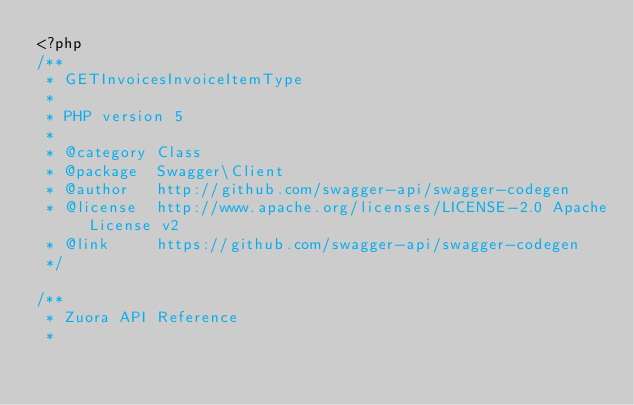Convert code to text. <code><loc_0><loc_0><loc_500><loc_500><_PHP_><?php
/**
 * GETInvoicesInvoiceItemType
 *
 * PHP version 5
 *
 * @category Class
 * @package  Swagger\Client
 * @author   http://github.com/swagger-api/swagger-codegen
 * @license  http://www.apache.org/licenses/LICENSE-2.0 Apache License v2
 * @link     https://github.com/swagger-api/swagger-codegen
 */

/**
 * Zuora API Reference
 *</code> 